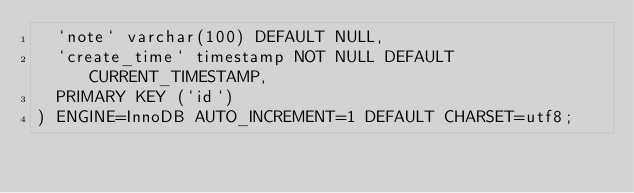Convert code to text. <code><loc_0><loc_0><loc_500><loc_500><_SQL_>  `note` varchar(100) DEFAULT NULL,
  `create_time` timestamp NOT NULL DEFAULT CURRENT_TIMESTAMP,
  PRIMARY KEY (`id`)
) ENGINE=InnoDB AUTO_INCREMENT=1 DEFAULT CHARSET=utf8;
</code> 